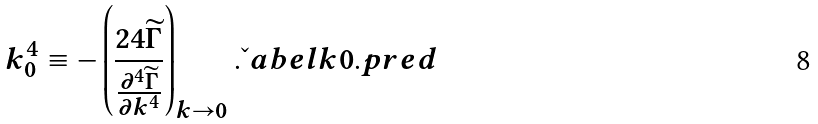<formula> <loc_0><loc_0><loc_500><loc_500>k _ { 0 } ^ { 4 } \equiv - \left ( \frac { 2 4 \widetilde { \Gamma } } { \frac { \partial ^ { 4 } \widetilde { \Gamma } } { \partial k ^ { 4 } } } \right ) _ { k \to 0 } . \L a b e l { k 0 . p r e d }</formula> 